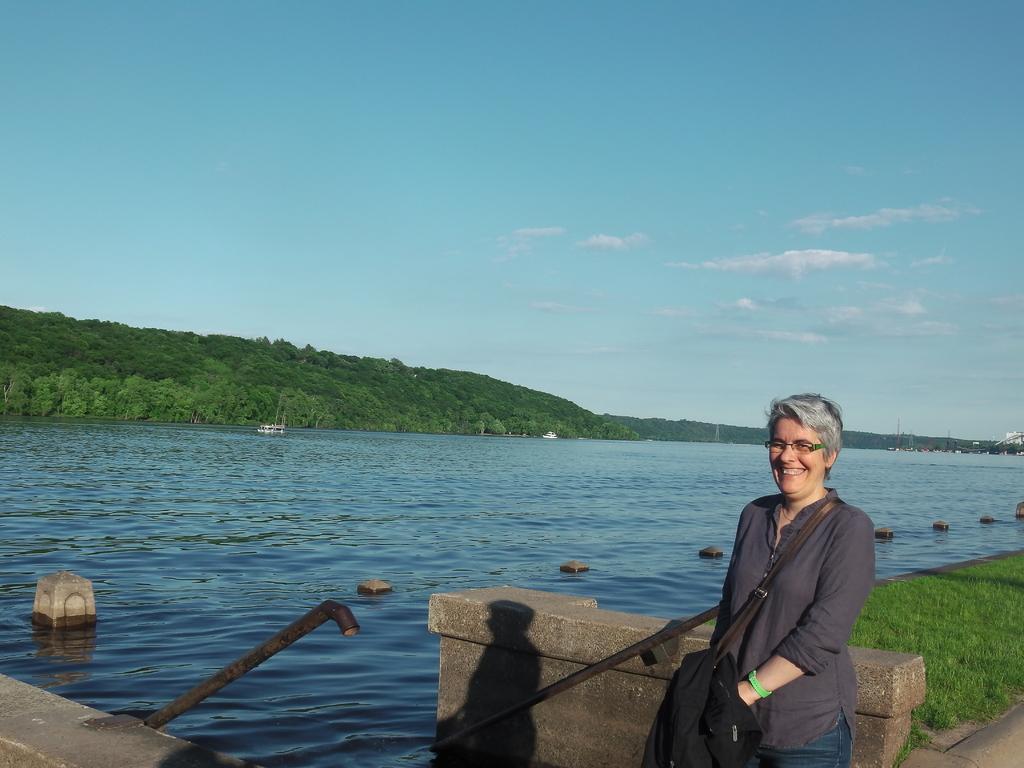Can you describe this image briefly? In this image we can see a person and the person is wearing a bag. Behind the person we can see a wall, poles, water and grass. In the water we can see boats and pillars. Behind the water, there are groups of trees. At the top we can see the sky. 